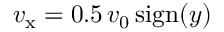Convert formula to latex. <formula><loc_0><loc_0><loc_500><loc_500>v _ { x } = 0 . 5 \, v _ { 0 } \, s i g n ( y )</formula> 